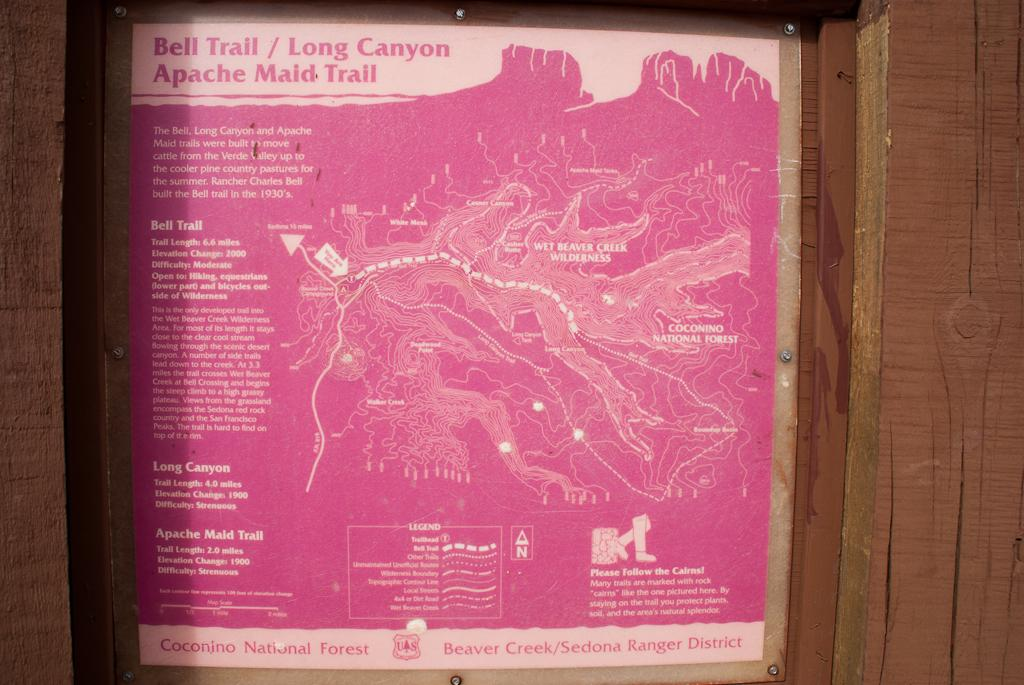<image>
Offer a succinct explanation of the picture presented. Bell Trail is on a map and details about the trail 